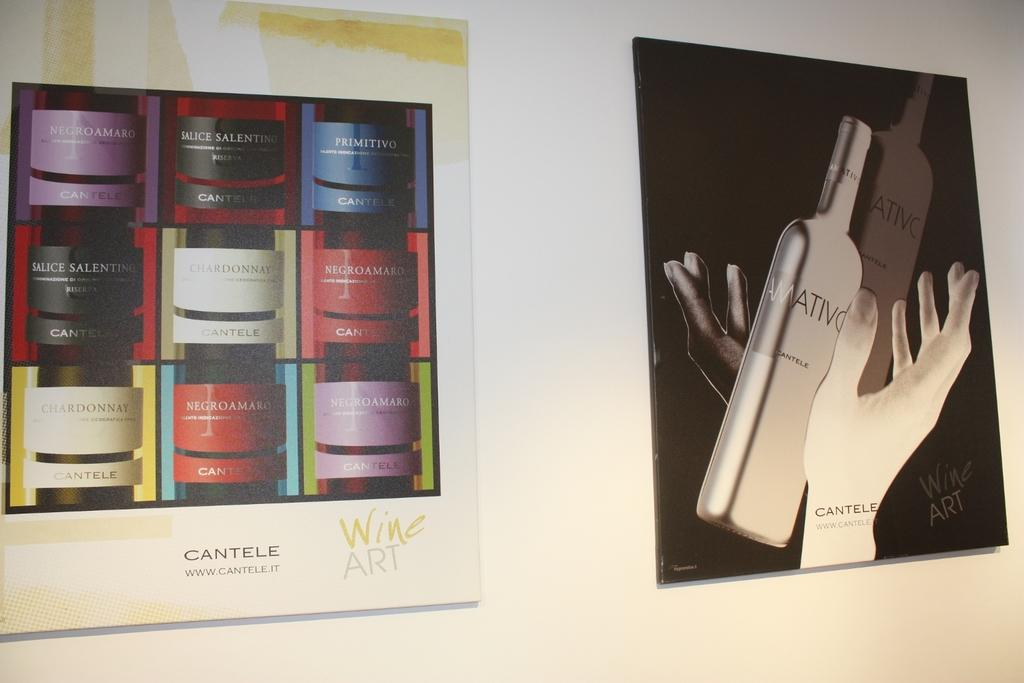<image>
Create a compact narrative representing the image presented. Hands catching a bottle of wine is one of two Wine Art pictures displayed on a wall. 